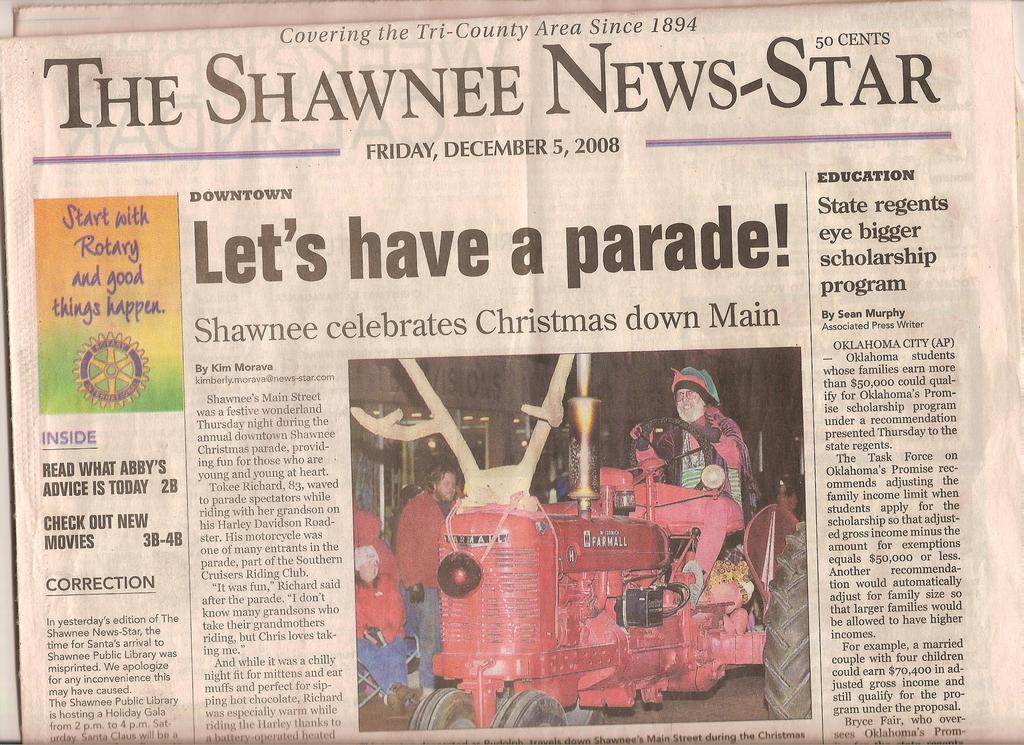<image>
Present a compact description of the photo's key features. a newspaper cover that says 'let's have a parade!' on it 